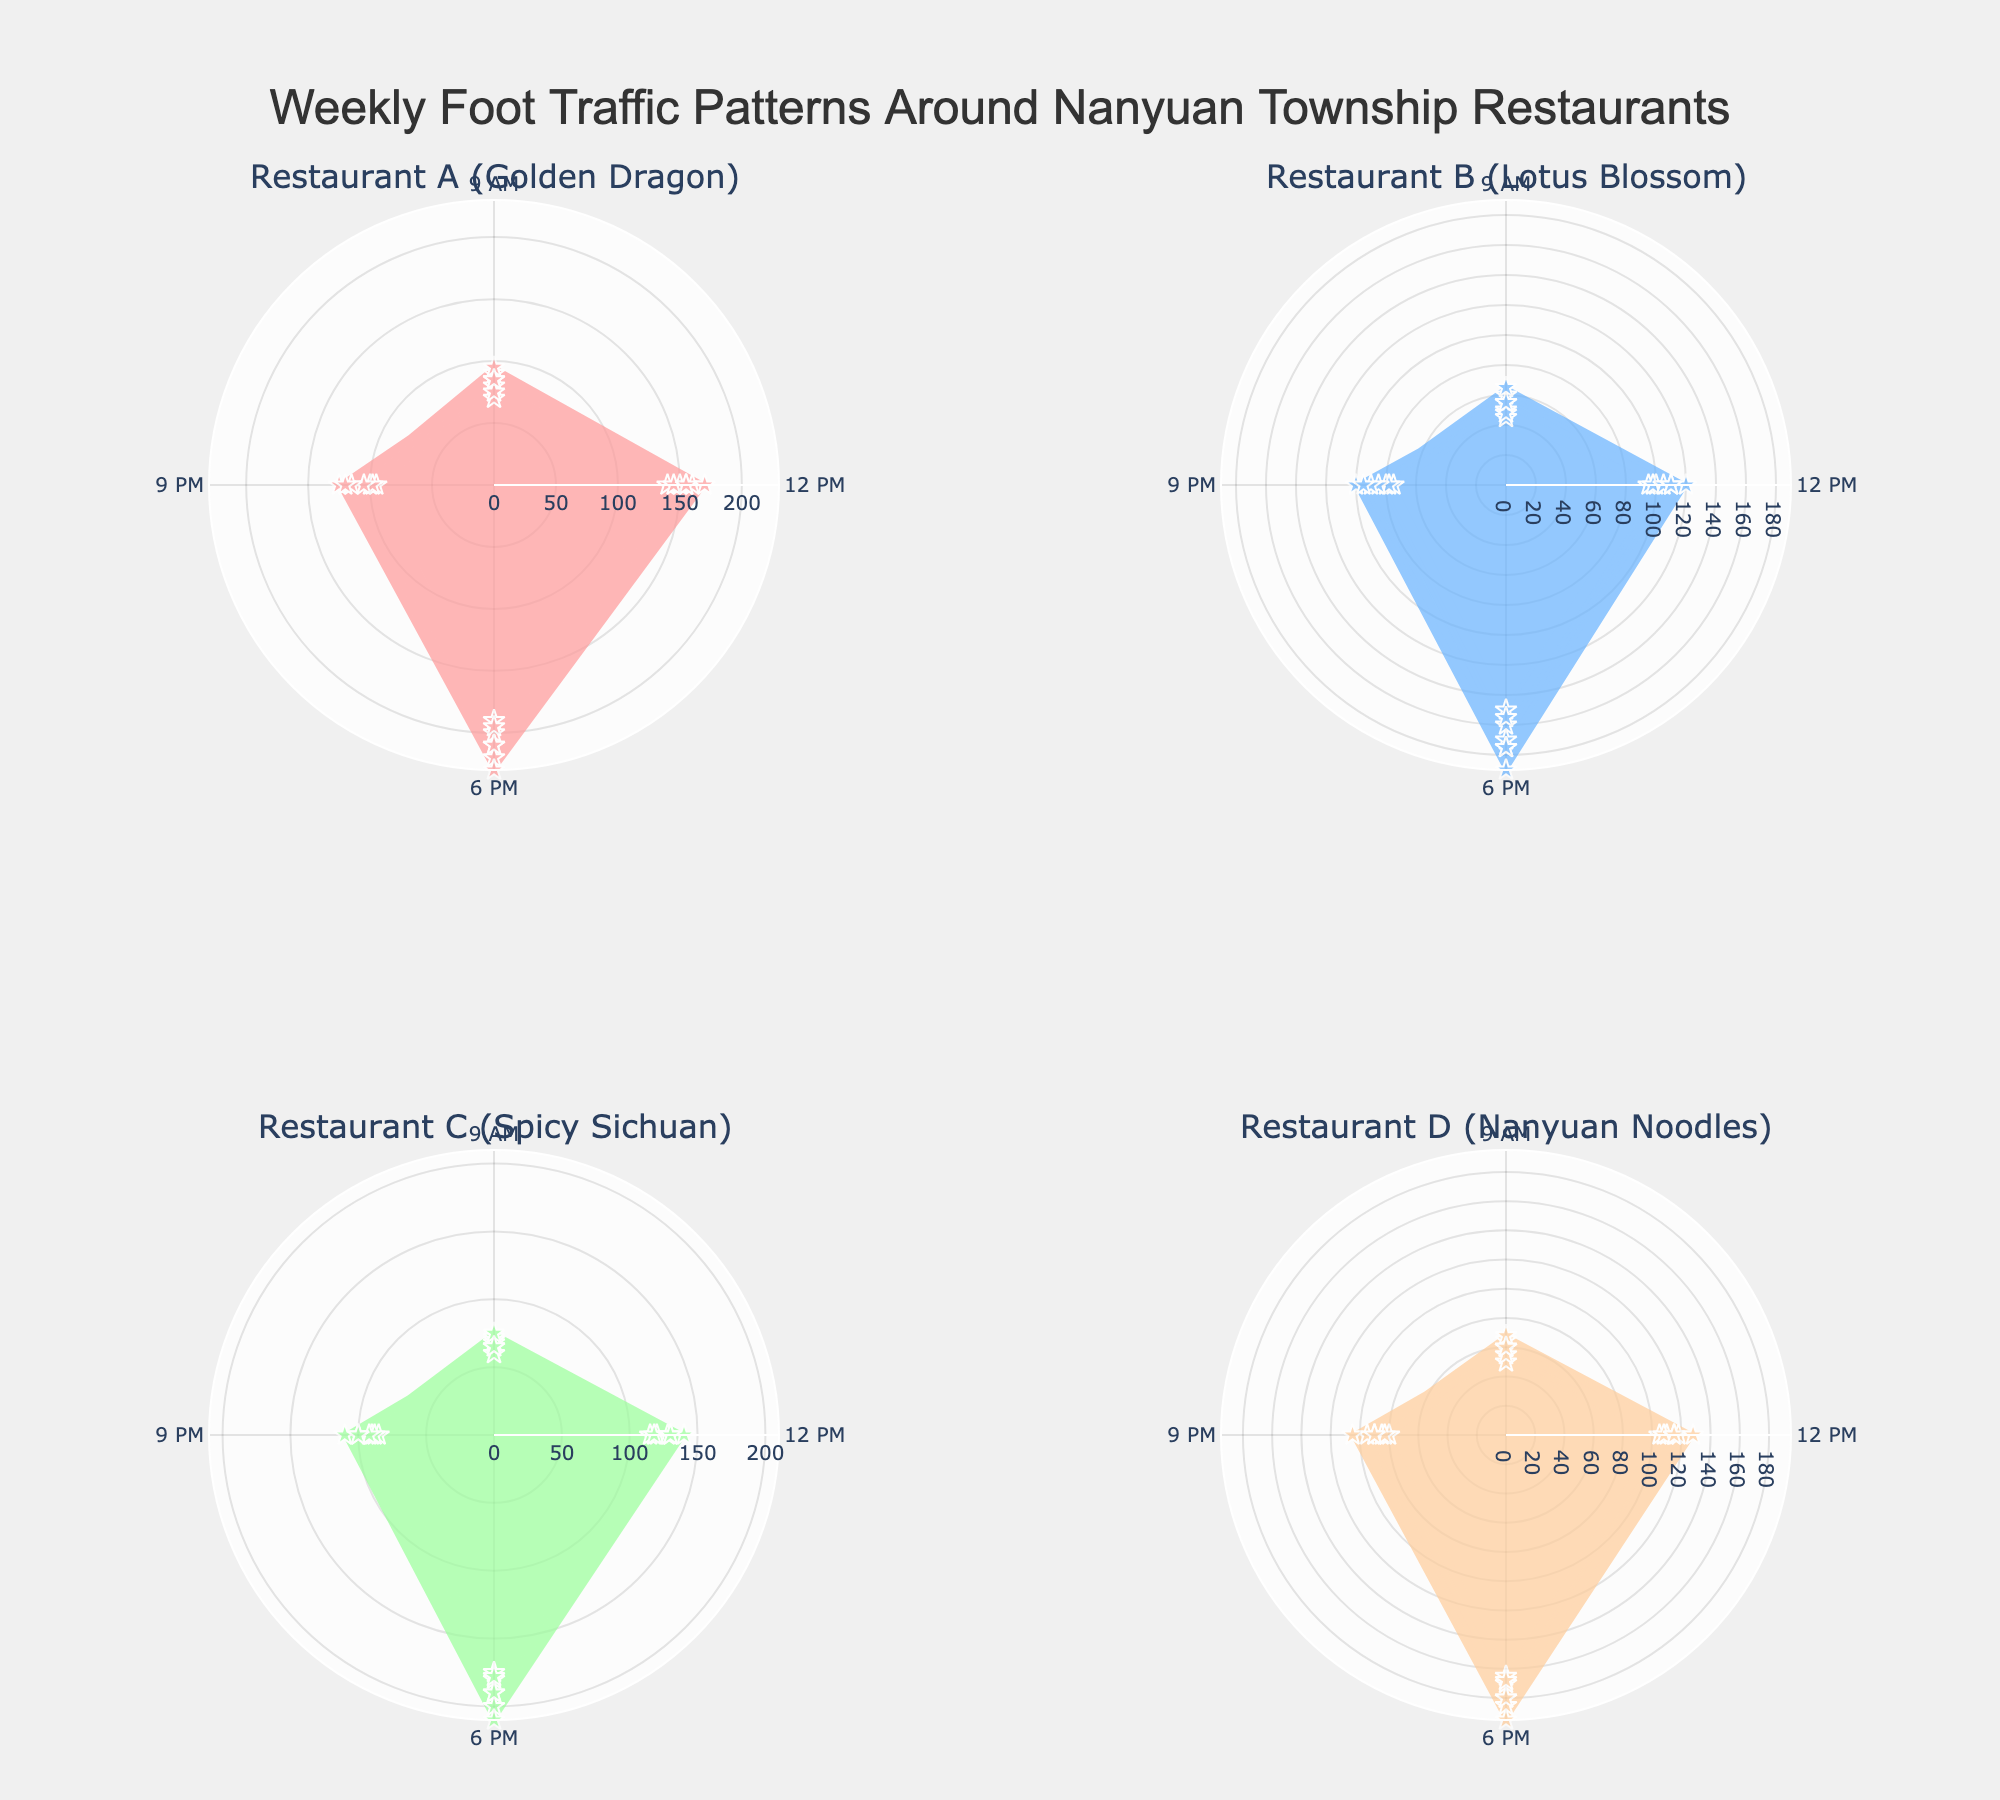What's the title of the chart? The title is shown at the top center of the figure. It reads 'Weekly Foot Traffic Patterns Around Nanyuan Township Restaurants'.
Answer: Weekly Foot Traffic Patterns Around Nanyuan Township Restaurants How many restaurants are displayed in the subplots? Each subplot corresponds to one restaurant. By looking at each of the four subplot titles, we see the figure displays four restaurants.
Answer: Four Which restaurant has the highest foot traffic at 6 PM on Saturday? To find this, look at the radial distance at the 6 PM point on Saturday for each restaurant. The plot for Restaurant A (Golden Dragon) shows the highest value at 230 units.
Answer: Restaurant A (Golden Dragon) What day has the lowest foot traffic for Restaurant D (Nanyuan Noodles) at 9 AM? Check the radial distances at the 9 AM mark for each day in the subplot for Restaurant D. The lowest value appears on Tuesday, with 50 units.
Answer: Tuesday Compare the foot traffic of Restaurant B (Lotus Blossom) and Restaurant C (Spicy Sichuan) at 9 PM on Friday. Which one is higher? Look at the 9 PM mark on Friday in both subplots. Restaurant B (Lotus Blossom) has a foot traffic of 90, while Restaurant C (Spicy Sichuan) has 100. Therefore, Restaurant C has higher foot traffic.
Answer: Restaurant C (Spicy Sichuan) What's the average foot traffic for Restaurant A (Golden Dragon) at 12 PM over the entire week? Add the foot traffic values for each day at 12 PM for Restaurant A and divide by the number of days. (150+140+145+155+160+170+155)/7 = 153.57.
Answer: 153.57 On which day is the foot traffic at Restaurant C (Spicy Sichuan) highest at 6 PM, and what is the value? Check the 6 PM mark for all days in the Restaurant C subplot. Saturday has the highest value at 210.
Answer: Saturday, 210 Which restaurant has the second-highest foot traffic at 9 PM on Sunday? Compare the radial distances at 9 PM on Sunday in all subplots. Hotel A has 120, Hotel B has 95, Hotel C has 100, and Hotel D has 90. The second-highest is Hotel C with 100.
Answer: Restaurant C (Spicy Sichuan) What's the difference in foot traffic at 12 PM between Monday and Friday for Restaurant D (Nanyuan Noodles)? The 12 PM values for Restaurant D on Monday and Friday are 110 and 118, respectively. The difference is 118 - 110 = 8.
Answer: 8 